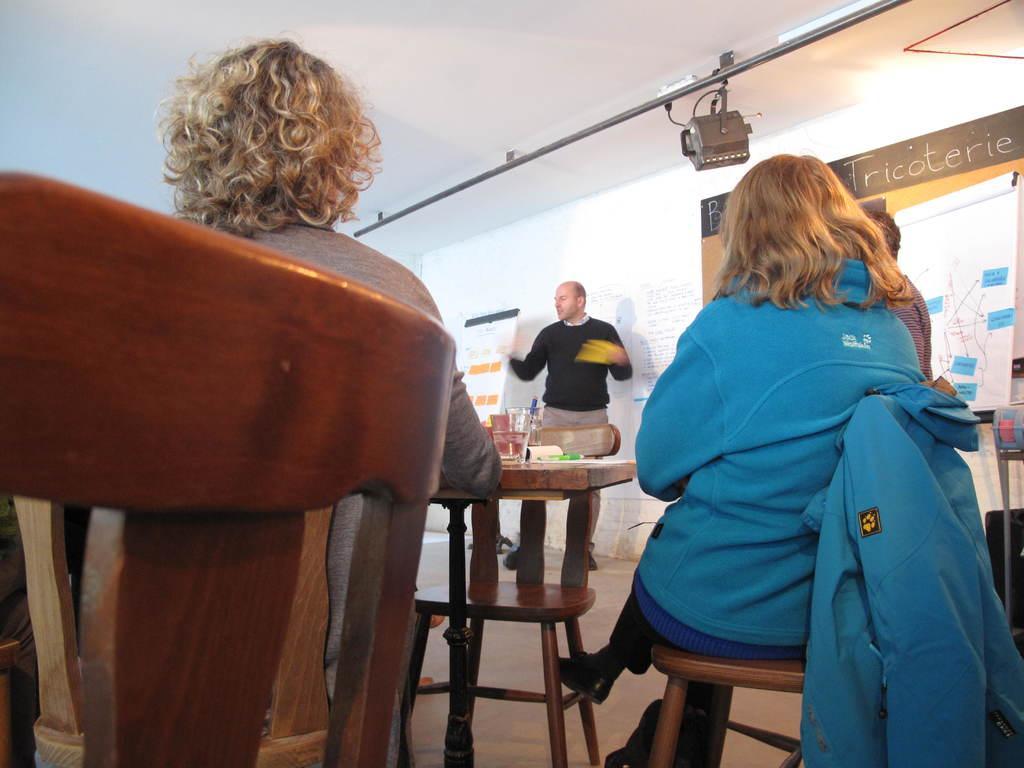How would you summarize this image in a sentence or two? In the image we can see there are people sitting on the chair and there is a man standing near the wall. There is a banner on the wall and there is a glass of water kept on the table. 